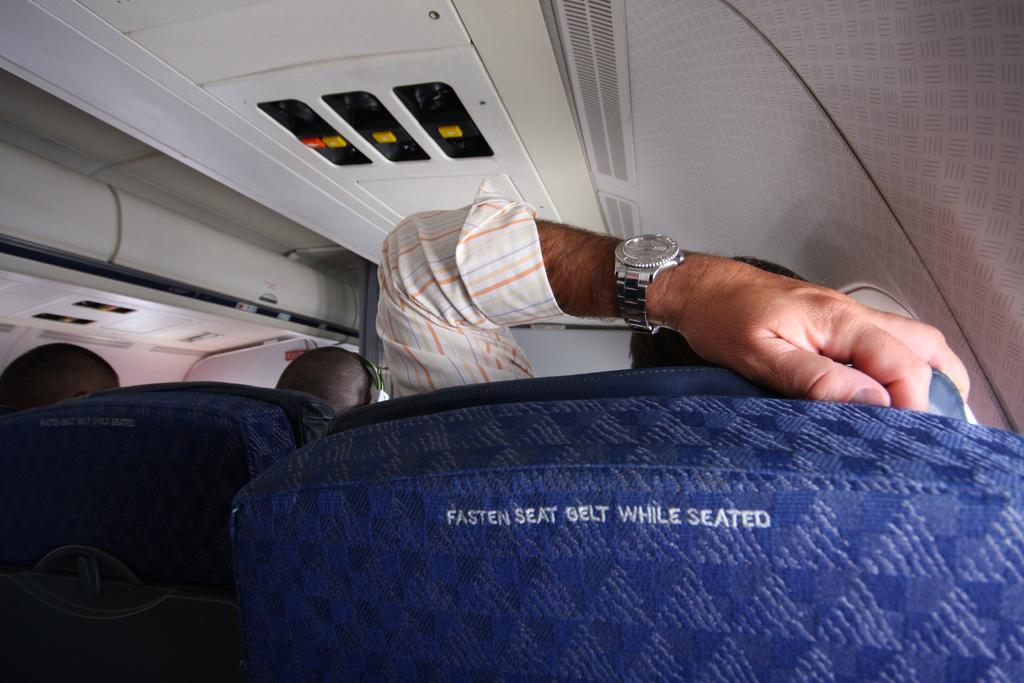Provide a one-sentence caption for the provided image. A blue airplane seat with the words "Fasten Seat belt While Seated" on the back. 